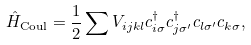Convert formula to latex. <formula><loc_0><loc_0><loc_500><loc_500>\hat { H } _ { \text {Coul} } = \frac { 1 } { 2 } \sum V _ { i j k l } c ^ { \dag } _ { i \sigma } c ^ { \dag } _ { j \sigma ^ { \prime } } c _ { l \sigma ^ { \prime } } c _ { k \sigma } ,</formula> 